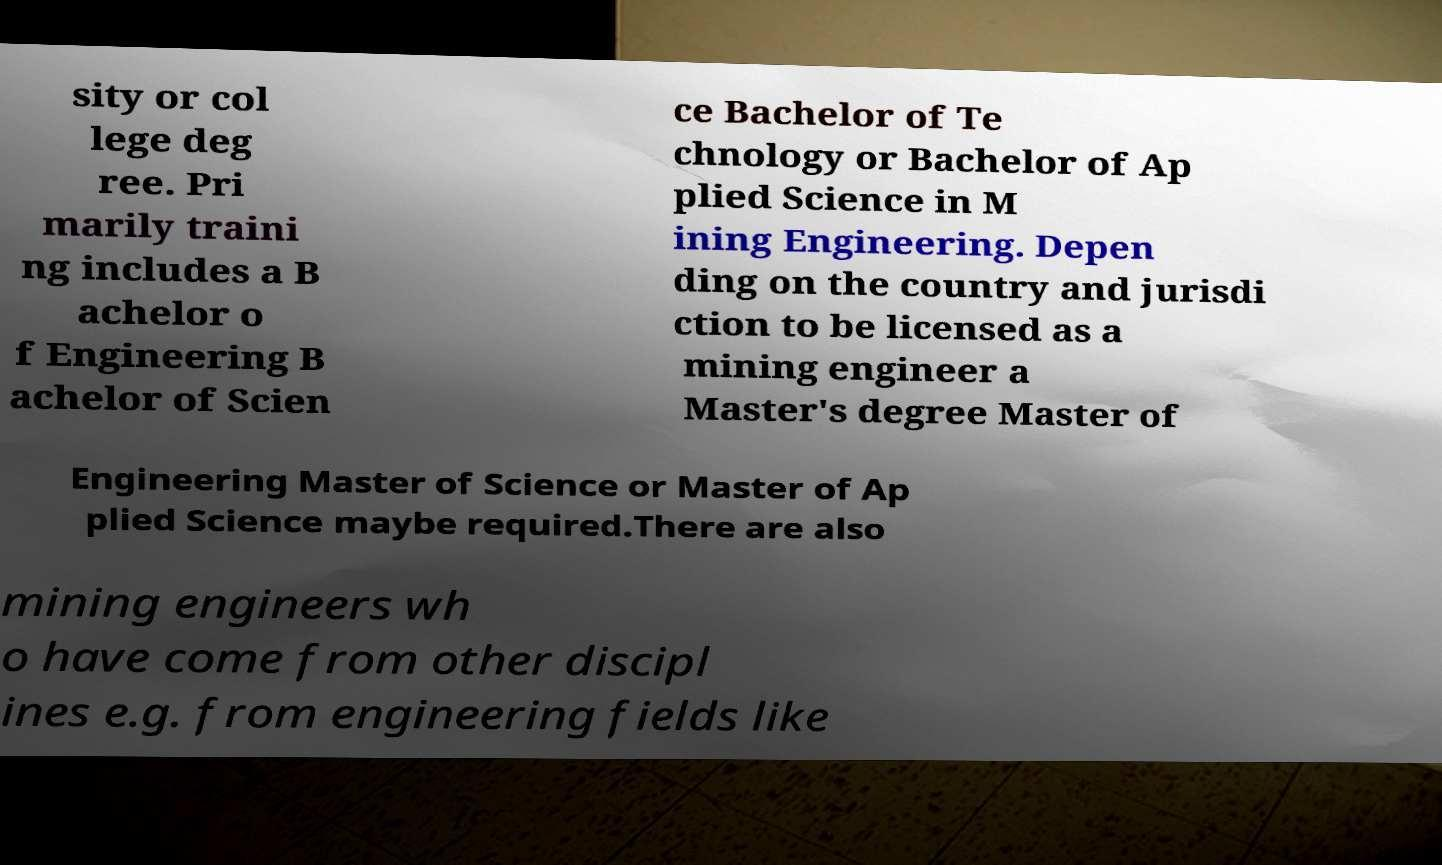I need the written content from this picture converted into text. Can you do that? sity or col lege deg ree. Pri marily traini ng includes a B achelor o f Engineering B achelor of Scien ce Bachelor of Te chnology or Bachelor of Ap plied Science in M ining Engineering. Depen ding on the country and jurisdi ction to be licensed as a mining engineer a Master's degree Master of Engineering Master of Science or Master of Ap plied Science maybe required.There are also mining engineers wh o have come from other discipl ines e.g. from engineering fields like 